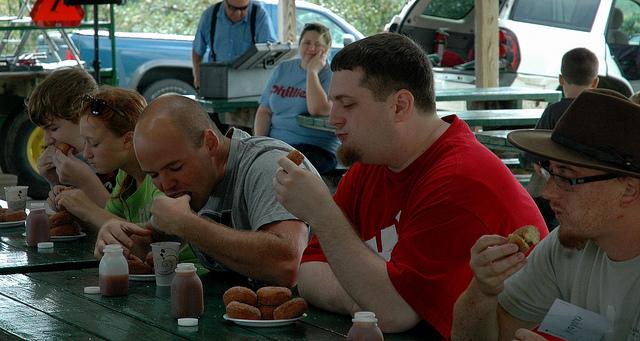Is it an eating contest or a restaurant?
Concise answer only. Eating contest. How many people are participating in the eating contest?
Give a very brief answer. 5. What color is the boys drink?
Concise answer only. Brown. What are they eating?
Concise answer only. Donuts. 